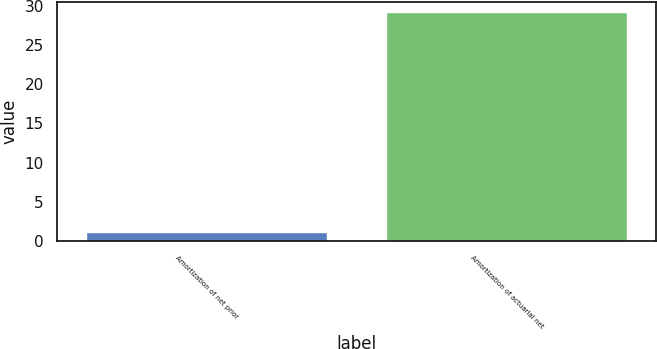<chart> <loc_0><loc_0><loc_500><loc_500><bar_chart><fcel>Amortization of net prior<fcel>Amortization of actuarial net<nl><fcel>1<fcel>29<nl></chart> 